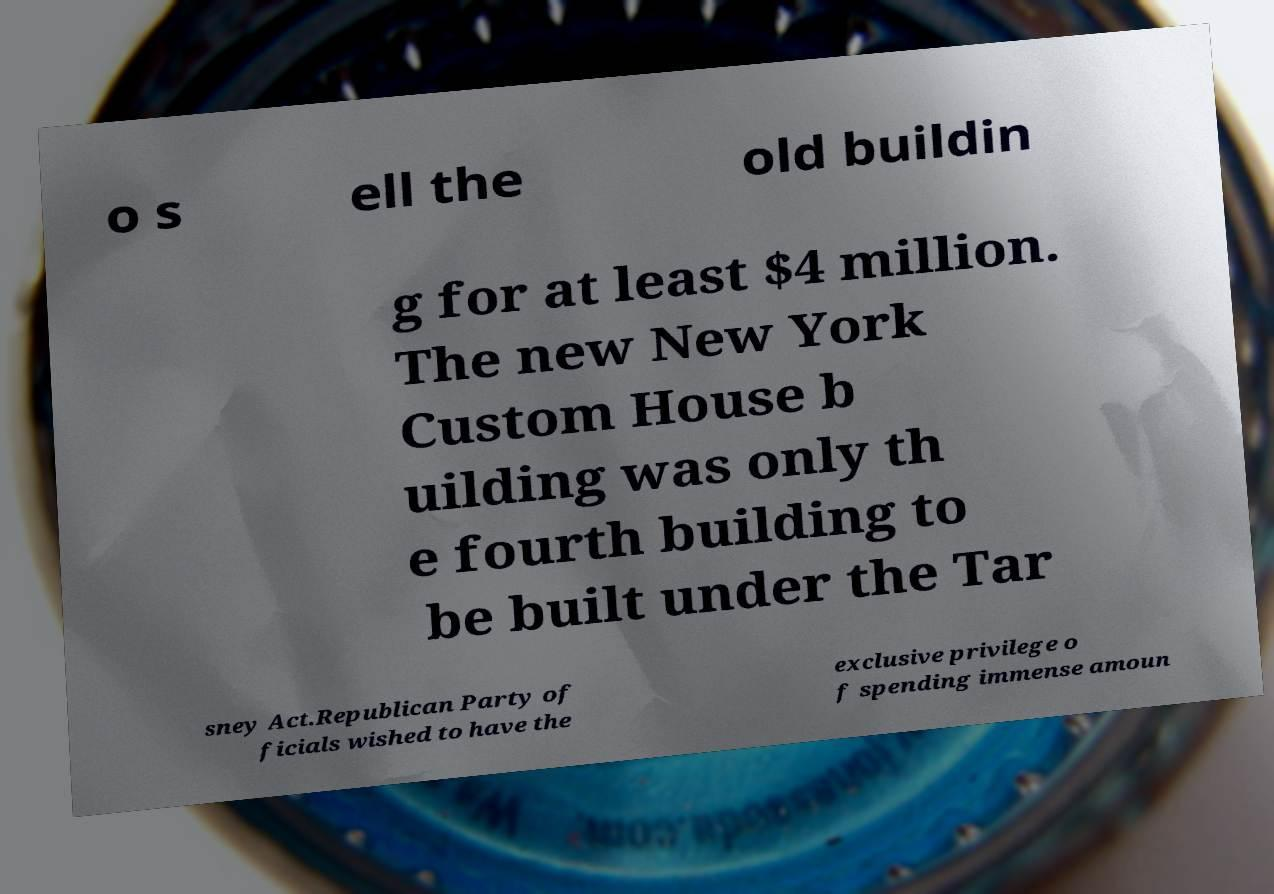What messages or text are displayed in this image? I need them in a readable, typed format. o s ell the old buildin g for at least $4 million. The new New York Custom House b uilding was only th e fourth building to be built under the Tar sney Act.Republican Party of ficials wished to have the exclusive privilege o f spending immense amoun 